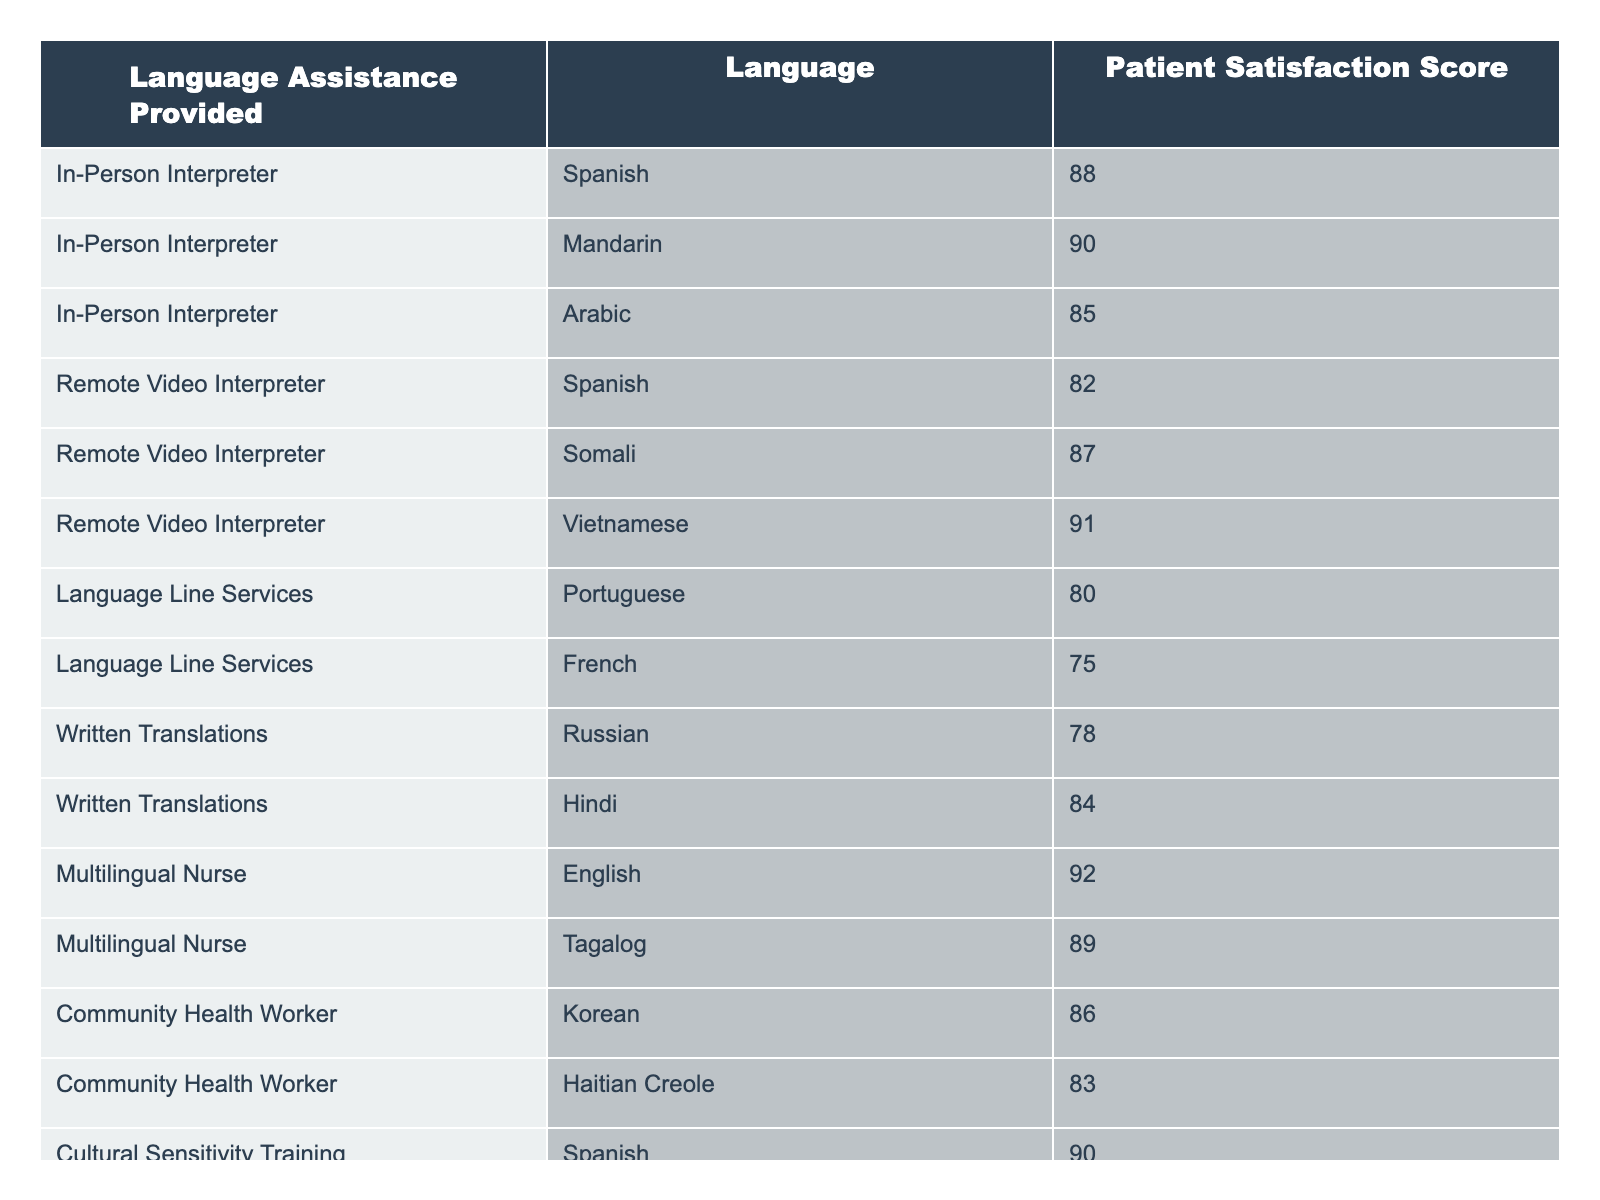What is the highest patient satisfaction score in the table? The table indicates the patient satisfaction scores, and upon inspection, the highest score is 92 associated with the "Multilingual Nurse" providing assistance in English.
Answer: 92 Which language assistance method received the lowest patient satisfaction score? Looking at the provided scores, "Language Line Services" with Portuguese has the lowest score of 80.
Answer: 80 What is the average patient satisfaction score for Spanish language assistance? The scores for Spanish language assistance are 88 (In-Person Interpreter) and 82 (Remote Video Interpreter). The average is calculated as (88 + 82) / 2 = 85.
Answer: 85 Is the patient satisfaction score for Romanian higher than that for Hindi? Romanian is not listed in the table, thus it has no score. The score for Hindi is 84. So the statement is false.
Answer: No How does the patient satisfaction score for 'Cultural Sensitivity Training' in German compare to 'In-Person Interpreter' in Arabic? The score for 'Cultural Sensitivity Training' (German) is 88, while for 'In-Person Interpreter' (Arabic) it is 85. Since 88 is greater than 85, the score for German is higher.
Answer: German is higher Which language assistance method has an average score above 85? Calculating the average scores: "In-Person Interpreter": (88 + 90 + 85) / 3 = 87.67, "Remote Video Interpreter": (82 + 87 + 91) / 3 = 86.67, "Language Line Services": (80 + 75) / 2 = 77.5, "Written Translations": (78 + 84) / 2 = 81, "Multilingual Nurse": (92 + 89) / 2 = 90.5, "Community Health Worker": (86 + 83) / 2 = 84.5, "Cultural Sensitivity Training": (90 + 88) / 2 = 89. Thus "In-Person Interpreter", "Remote Video Interpreter", "Multilingual Nurse", and "Cultural Sensitivity Training" all have averages above 85.
Answer: In-Person Interpreter, Remote Video Interpreter, Multilingual Nurse, Cultural Sensitivity Training How many languages were provided assistance for under the "Written Translations" method? The table lists two languages under "Written Translations": Russian and Hindi. Therefore, the total number of languages is 2.
Answer: 2 